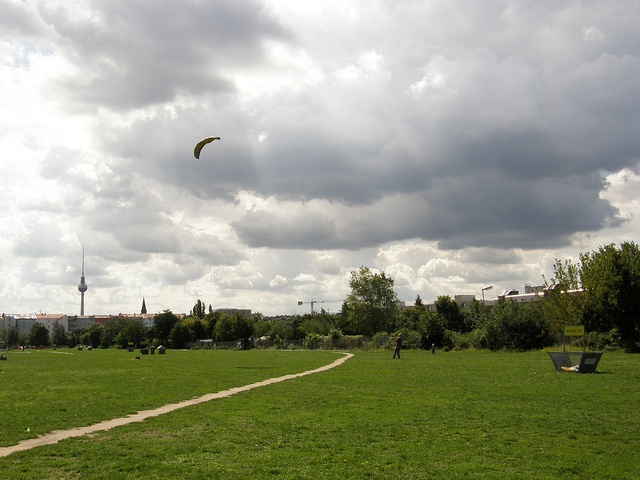Describe the objects in this image and their specific colors. I can see people in lightgray, black, darkgreen, gray, and maroon tones, kite in lightgray, black, darkgreen, and gray tones, and people in lightgray, black, maroon, and olive tones in this image. 